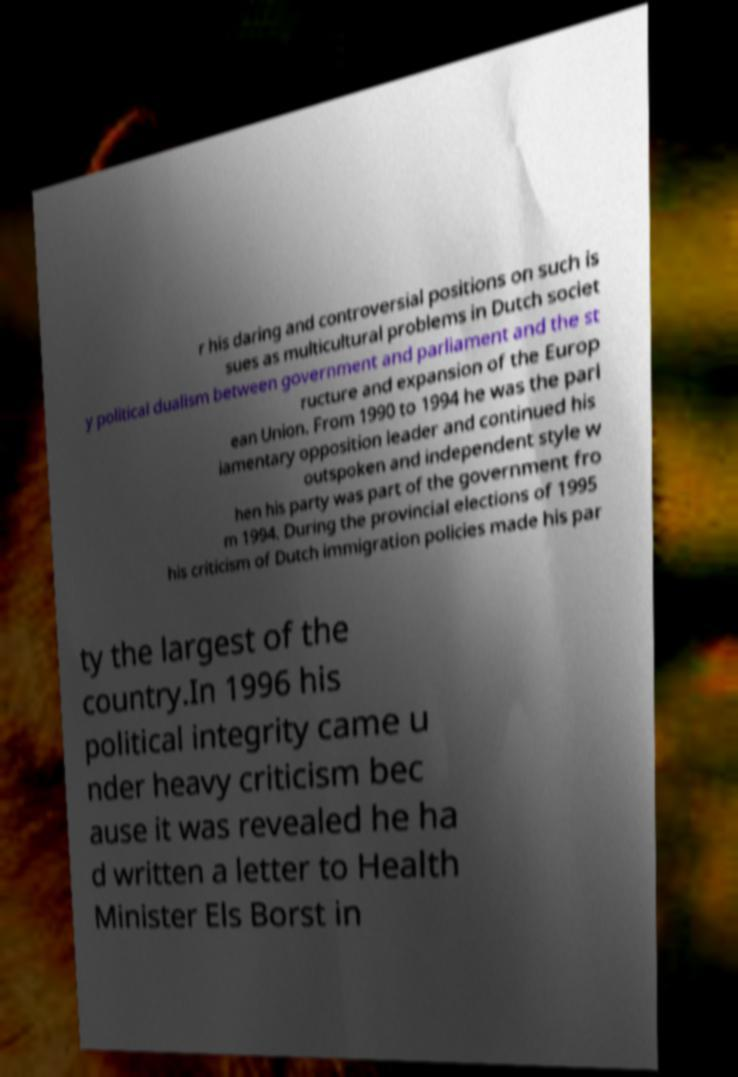Please read and relay the text visible in this image. What does it say? r his daring and controversial positions on such is sues as multicultural problems in Dutch societ y political dualism between government and parliament and the st ructure and expansion of the Europ ean Union. From 1990 to 1994 he was the parl iamentary opposition leader and continued his outspoken and independent style w hen his party was part of the government fro m 1994. During the provincial elections of 1995 his criticism of Dutch immigration policies made his par ty the largest of the country.In 1996 his political integrity came u nder heavy criticism bec ause it was revealed he ha d written a letter to Health Minister Els Borst in 